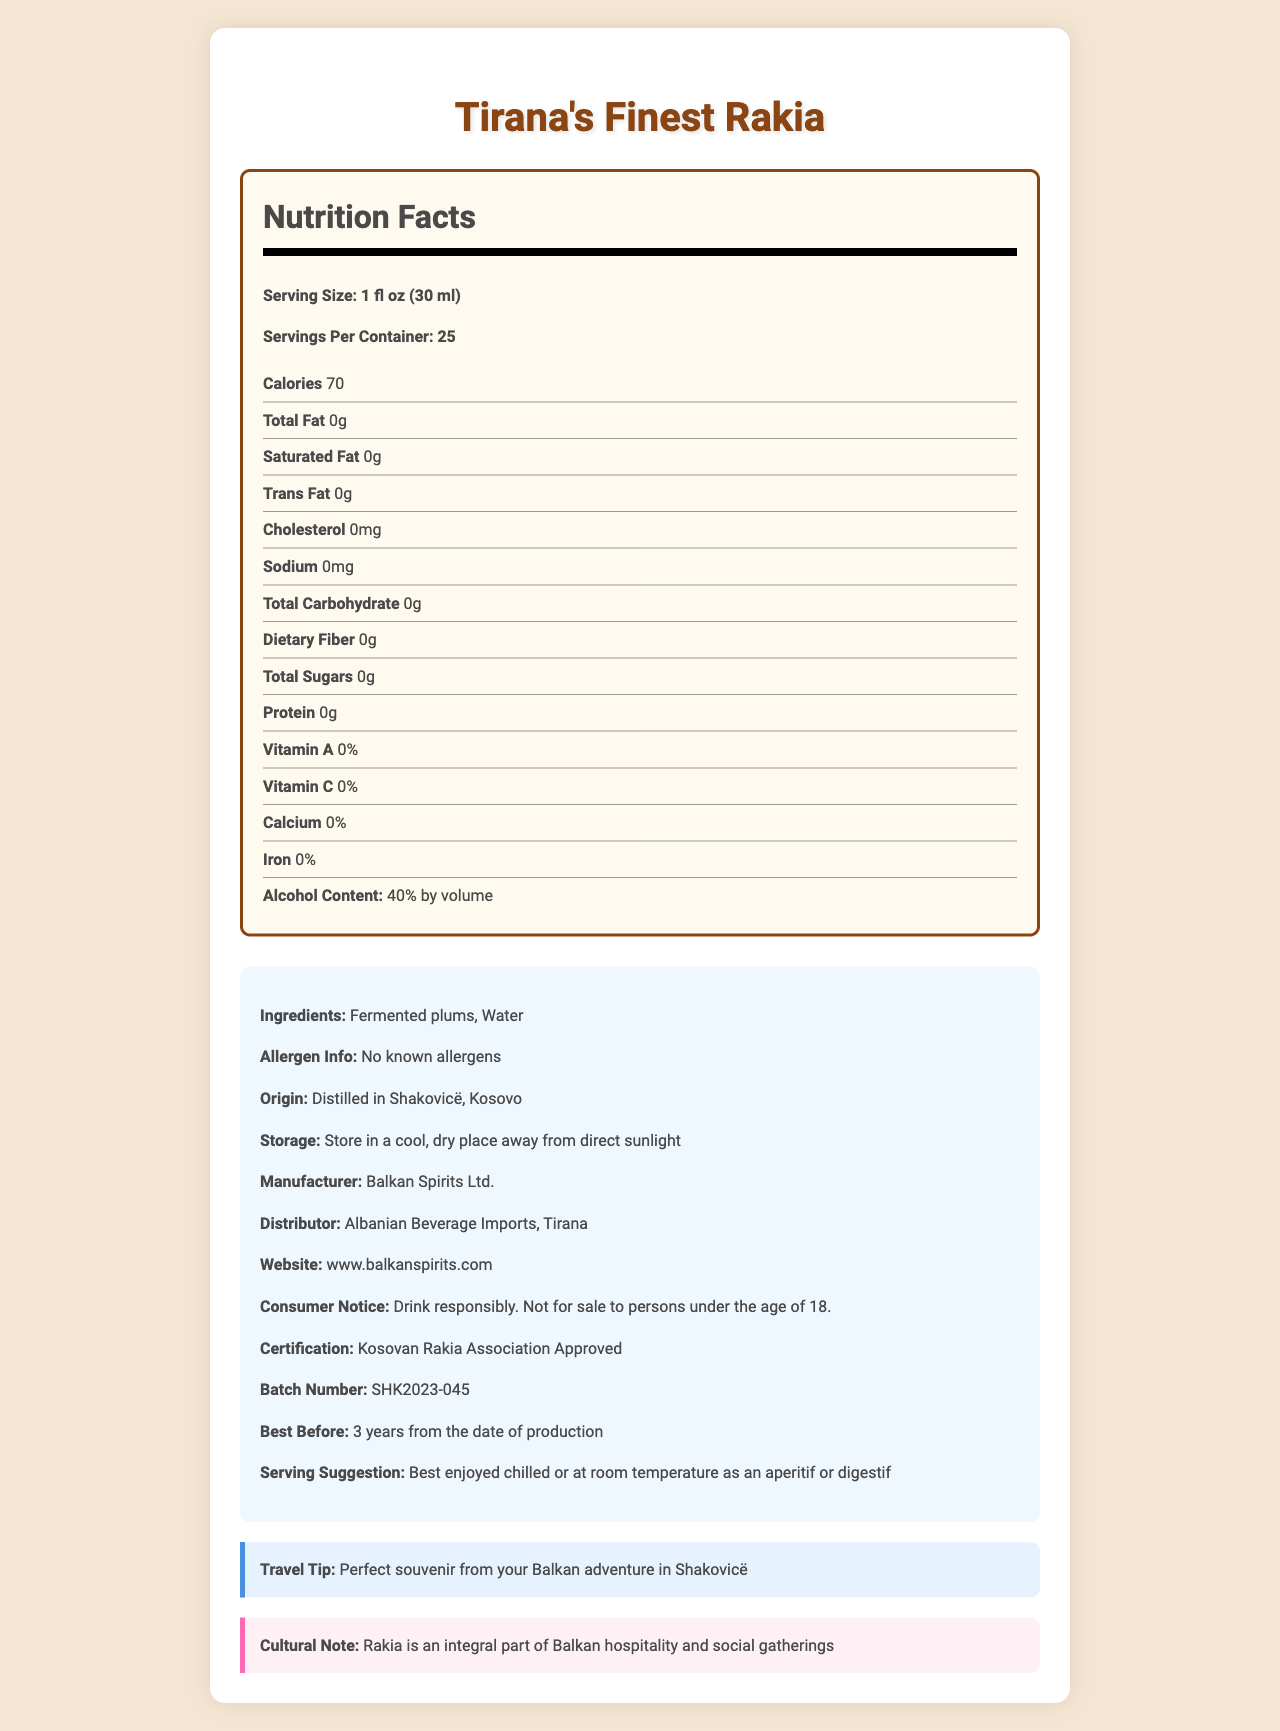who manufactures Tirana's Finest Rakia? The document states that the manufacturer is Balkan Spirits Ltd.
Answer: Balkan Spirits Ltd. what is the alcohol content of the rakia? The Nutrition Facts section of the document lists the alcohol content as 40% by volume.
Answer: 40% by volume does the rakia contain any allergens? The allergen information in the document states that there are no known allergens.
Answer: No known allergens what is the serving size for Tirana's Finest Rakia? The document specifies that the serving size is 1 fl oz (30 ml).
Answer: 1 fl oz (30 ml) how many calories are in each serving of the rakia? The Nutrition Facts section indicates that each serving contains 70 calories.
Answer: 70 what are the ingredients of Tirana's Finest Rakia? The ingredients section of the document lists "Fermented plums" and "Water."
Answer: Fermented plums, Water where is the rakia distilled? The origin section of the document notes that the rakia is distilled in Shakovicë, Kosovo.
Answer: Shakovicë, Kosovo what is the best before duration for the rakia? The document states that the rakia is best before 3 years from the date of production.
Answer: 3 years from the date of production how many servings are in a container of Tirana's Finest Rakia? The Nutrition Facts section specifies that there are 25 servings per container.
Answer: 25 how should Tirana's Finest Rakia be stored? The storage instructions in the document advise to store the rakia in a cool, dry place away from direct sunlight.
Answer: Store in a cool, dry place away from direct sunlight what is the recommended method for enjoying Tirana's Finest Rakia? A. Heated B. Chilled or at room temperature C. Mixed with soda The document suggests that the rakia is best enjoyed chilled or at room temperature as an aperitif or digestif.
Answer: B who is the distributor of Tirana's Finest Rakia? A. Kosovo Beverage Co. B. Balkan Spirits Ltd. C. Albanian Beverage Imports The document indicates that the distributor is Albanian Beverage Imports.
Answer: C is Tirana's Finest Rakia suitable for persons under the age of 18? The consumer notice section clearly states that the product is not for sale to persons under the age of 18.
Answer: No what is the cultural significance of rakia in the Balkans? The cultural note section of the document explains that rakia is an integral part of Balkan hospitality and social gatherings.
Answer: Rakia is an integral part of Balkan hospitality and social gatherings is there any information about the health benefits of Tirana's Finest Rakia? The document does not provide any information about the health benefits of Tirana's Finest Rakia.
Answer: Not enough information please summarize the main idea of the document. The document gives an overview of the product, including its nutritional content, tips on storage and consumption, production details, and cultural importance.
Answer: The document provides detailed information about Tirana's Finest Rakia, a Balkan fruit brandy distilled in Shakovicë, Kosovo. It includes nutritional facts, ingredients, storage instructions, serving size, manufacturer and distributor details, and cultural notes highlighting its significance in Balkan hospitality. 